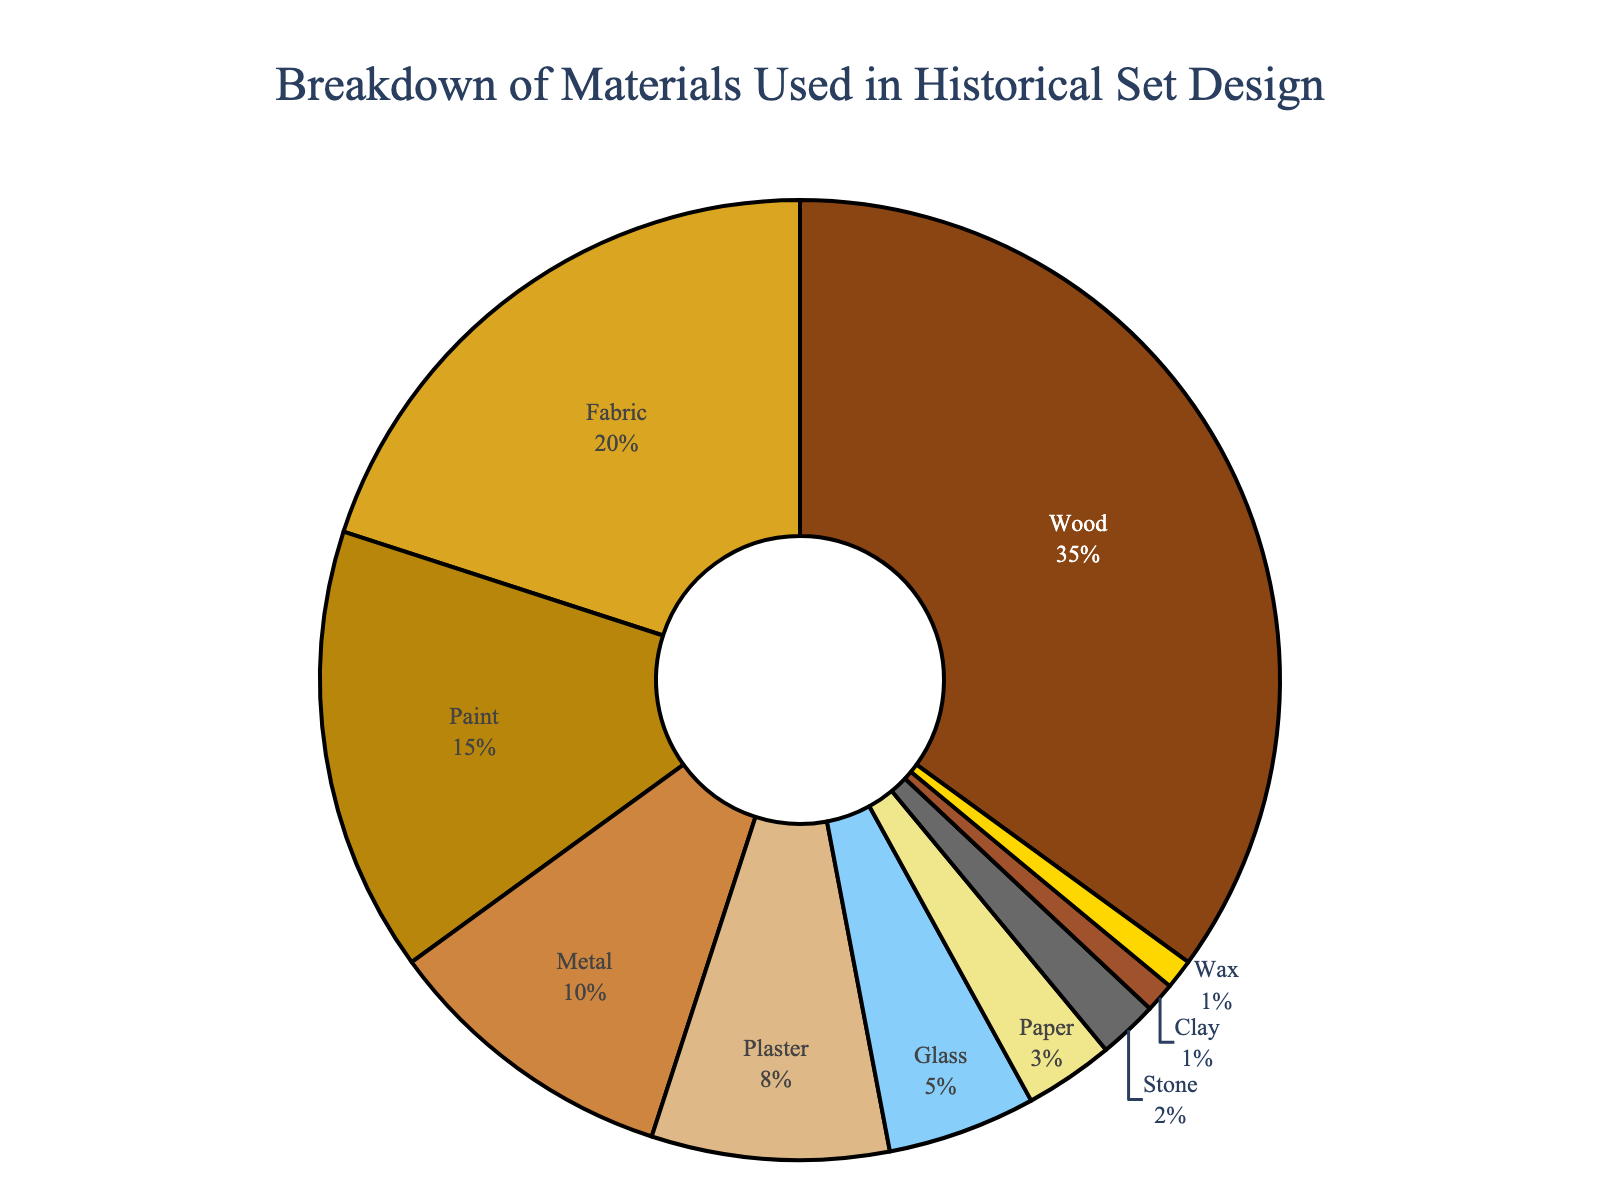Which material is used the most in historical set design? By examining the pie chart, we see that Wood occupies the largest section of the chart, indicating that it is used the most.
Answer: Wood Which material has a higher percentage, Fabric or Metal? By comparing the two sections of the pie chart, Fabric is shown to constitute 20% while Metal constitutes 10%. Therefore, Fabric has a higher percentage.
Answer: Fabric What is the total percentage of the three least used materials? The three least used materials are Stone (2%), Clay (1%), and Wax (1%). Adding these percentages: 2 + 1 + 1 = 4%.
Answer: 4% Which materials have a percentage value greater than 10%? The pie chart shows that Wood (35%), Fabric (20%), and Paint (15%) each have a percentage value greater than 10%.
Answer: Wood, Fabric, Paint What is the difference in percentage between the most used material and the least used material? The most used material is Wood (35%) and the least used materials are Clay and Wax (1% each). The difference in percentage is 35 - 1 = 34%.
Answer: 34% How much more is the percentage of Paint compared to Plaster? The percentage of Paint is 15% and the percentage of Plaster is 8%. Subtract the two to find the difference: 15 - 8 = 7%.
Answer: 7% What is the combined percentage of materials that account for more than 5% each? The materials with more than 5% each are Wood (35%), Fabric (20%), Paint (15%), Metal (10%), and Plaster (8%). Adding these percentages: 35 + 20 + 15 + 10 + 8 = 88%.
Answer: 88% What is the percentage of Glass, and what color represents it on the chart? By looking at the pie chart, Glass has a percentage of 5%. The section representing Glass is colored light blue.
Answer: 5%, light blue 